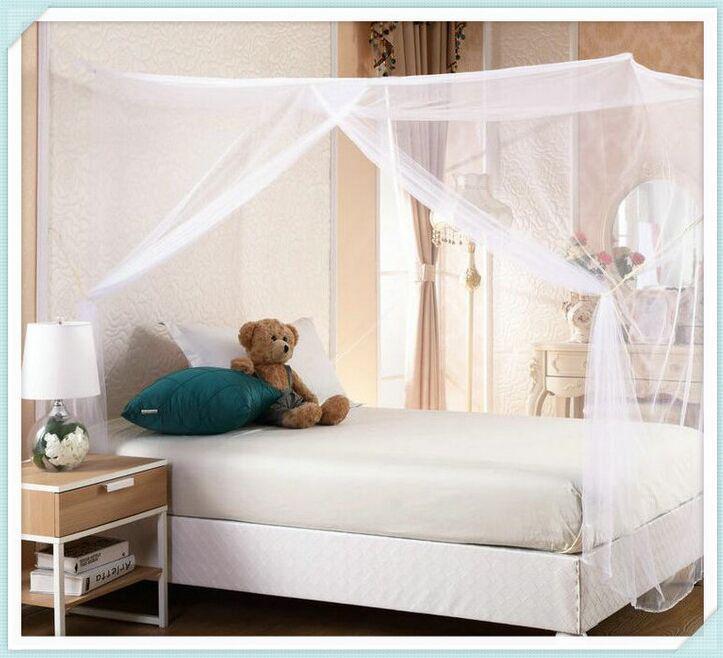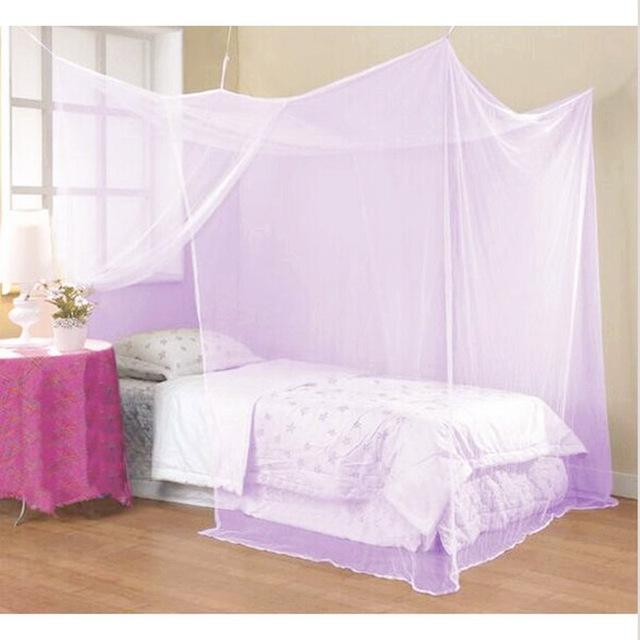The first image is the image on the left, the second image is the image on the right. Evaluate the accuracy of this statement regarding the images: "A bed with its pillow on the left and a cloth-covered table alongside it has a canopy with each corner lifted by a strap.". Is it true? Answer yes or no. Yes. The first image is the image on the left, the second image is the image on the right. For the images displayed, is the sentence "One mattress has no blanket, the other mattress has a light (mostly white) colored blanket." factually correct? Answer yes or no. Yes. 